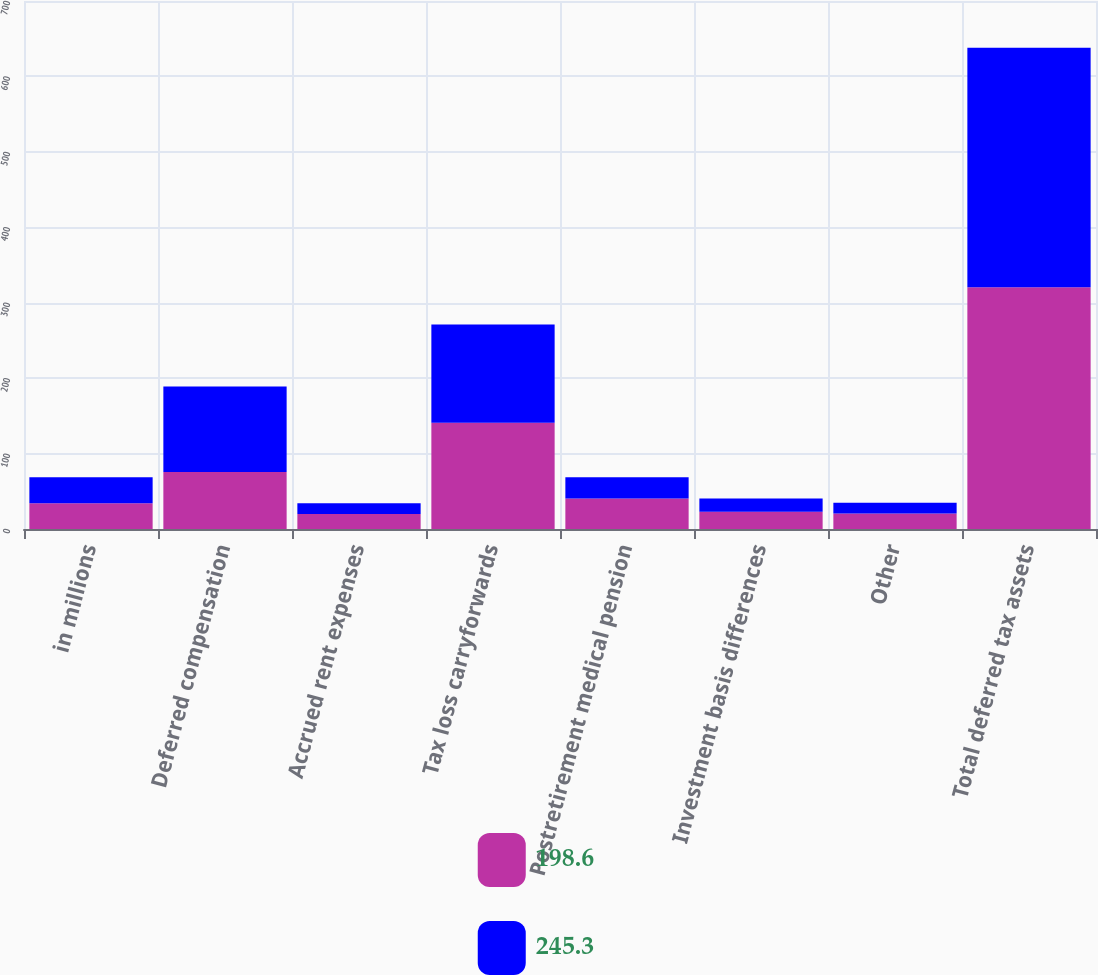<chart> <loc_0><loc_0><loc_500><loc_500><stacked_bar_chart><ecel><fcel>in millions<fcel>Deferred compensation<fcel>Accrued rent expenses<fcel>Tax loss carryforwards<fcel>Postretirement medical pension<fcel>Investment basis differences<fcel>Other<fcel>Total deferred tax assets<nl><fcel>198.6<fcel>34.3<fcel>75.7<fcel>19.9<fcel>140.9<fcel>40.4<fcel>22.9<fcel>20.6<fcel>320.4<nl><fcel>245.3<fcel>34.3<fcel>113.1<fcel>14.4<fcel>130.1<fcel>28.2<fcel>17.4<fcel>14.3<fcel>317.5<nl></chart> 